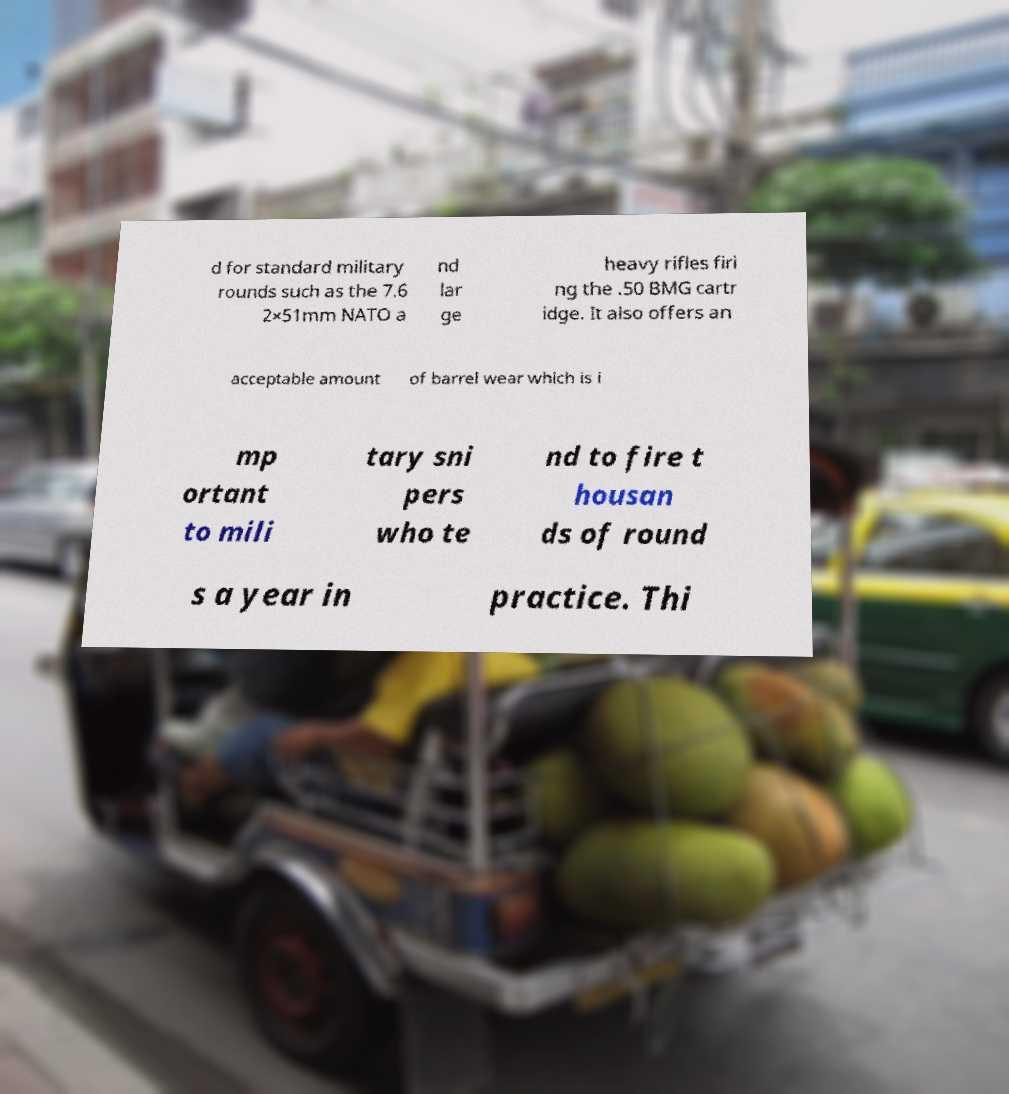Can you read and provide the text displayed in the image?This photo seems to have some interesting text. Can you extract and type it out for me? d for standard military rounds such as the 7.6 2×51mm NATO a nd lar ge heavy rifles firi ng the .50 BMG cartr idge. It also offers an acceptable amount of barrel wear which is i mp ortant to mili tary sni pers who te nd to fire t housan ds of round s a year in practice. Thi 